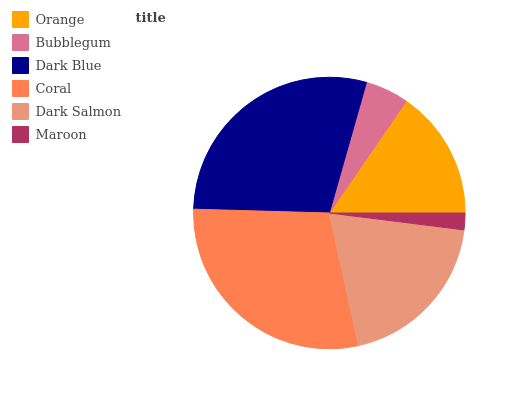Is Maroon the minimum?
Answer yes or no. Yes. Is Dark Blue the maximum?
Answer yes or no. Yes. Is Bubblegum the minimum?
Answer yes or no. No. Is Bubblegum the maximum?
Answer yes or no. No. Is Orange greater than Bubblegum?
Answer yes or no. Yes. Is Bubblegum less than Orange?
Answer yes or no. Yes. Is Bubblegum greater than Orange?
Answer yes or no. No. Is Orange less than Bubblegum?
Answer yes or no. No. Is Dark Salmon the high median?
Answer yes or no. Yes. Is Orange the low median?
Answer yes or no. Yes. Is Orange the high median?
Answer yes or no. No. Is Maroon the low median?
Answer yes or no. No. 